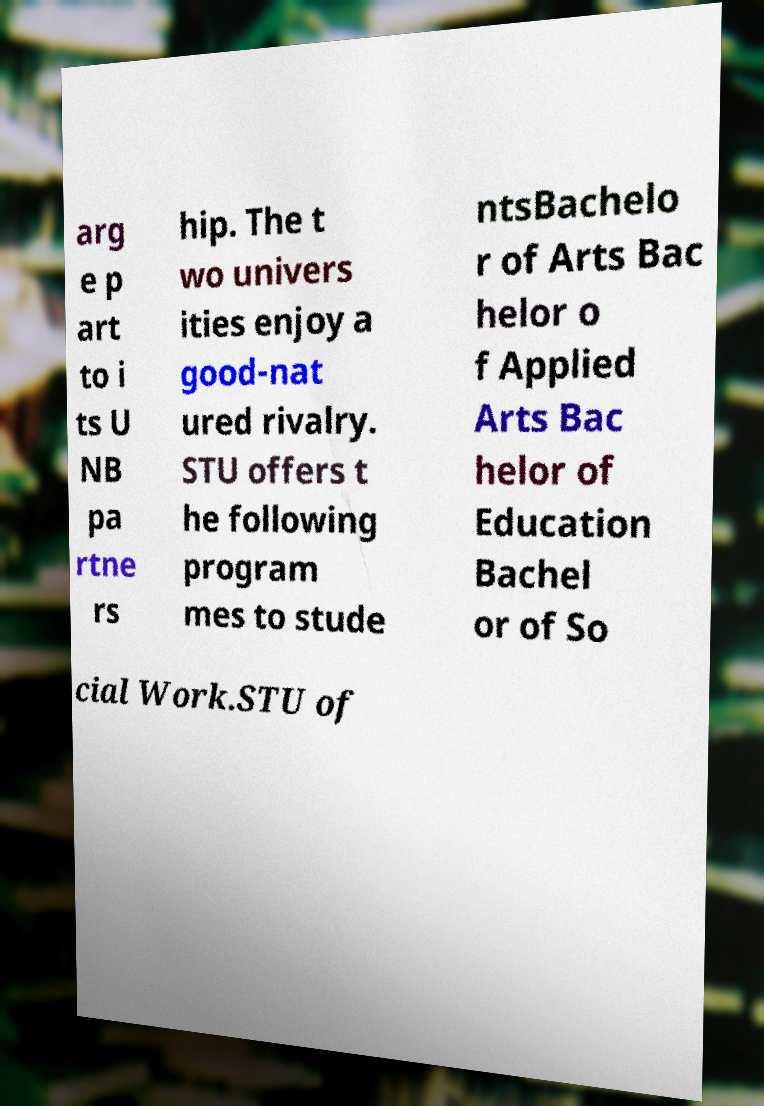Please identify and transcribe the text found in this image. arg e p art to i ts U NB pa rtne rs hip. The t wo univers ities enjoy a good-nat ured rivalry. STU offers t he following program mes to stude ntsBachelo r of Arts Bac helor o f Applied Arts Bac helor of Education Bachel or of So cial Work.STU of 